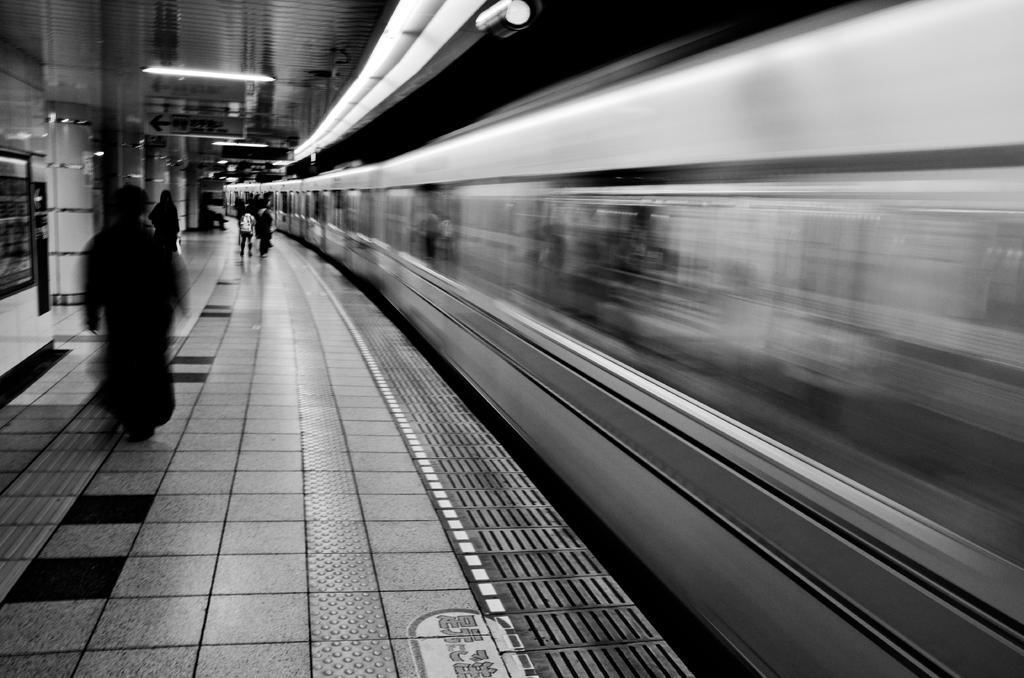Please provide a concise description of this image. In this picture we can see a train, beside this train we can see a platform, here we can see people, lights, pillars and some objects. 